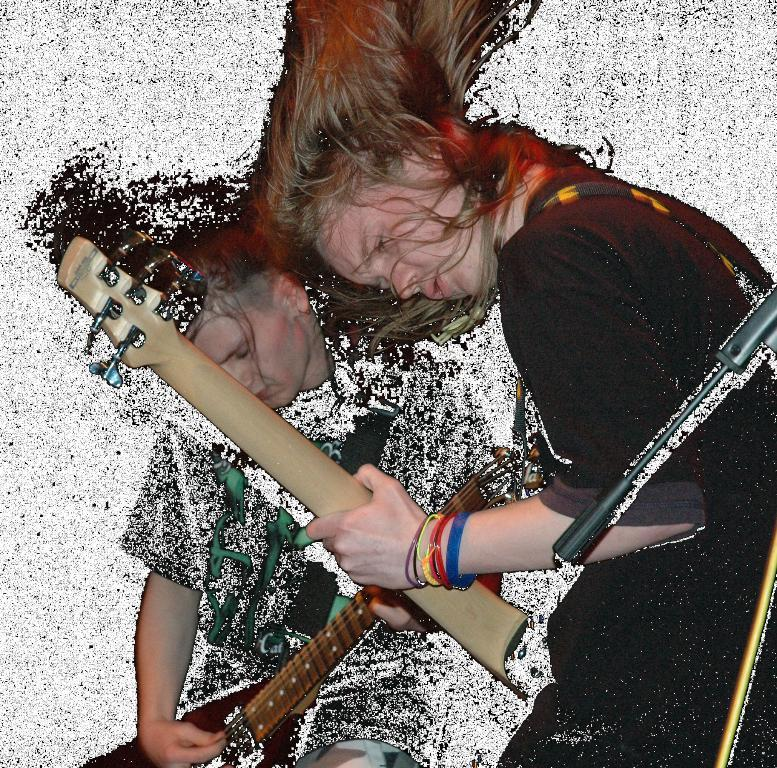How many people are in the image? There are two people in the image. What are the two people doing in the image? The two people are playing a musical instrument. Can you describe any other objects or features in the image? Yes, there is a stand on the right side of the image. How many notes can be seen on the stand in the image? There are no notes visible on the stand in the image. Can you tell me how many kittens are comforting the people in the image? There are no kittens present in the image. 